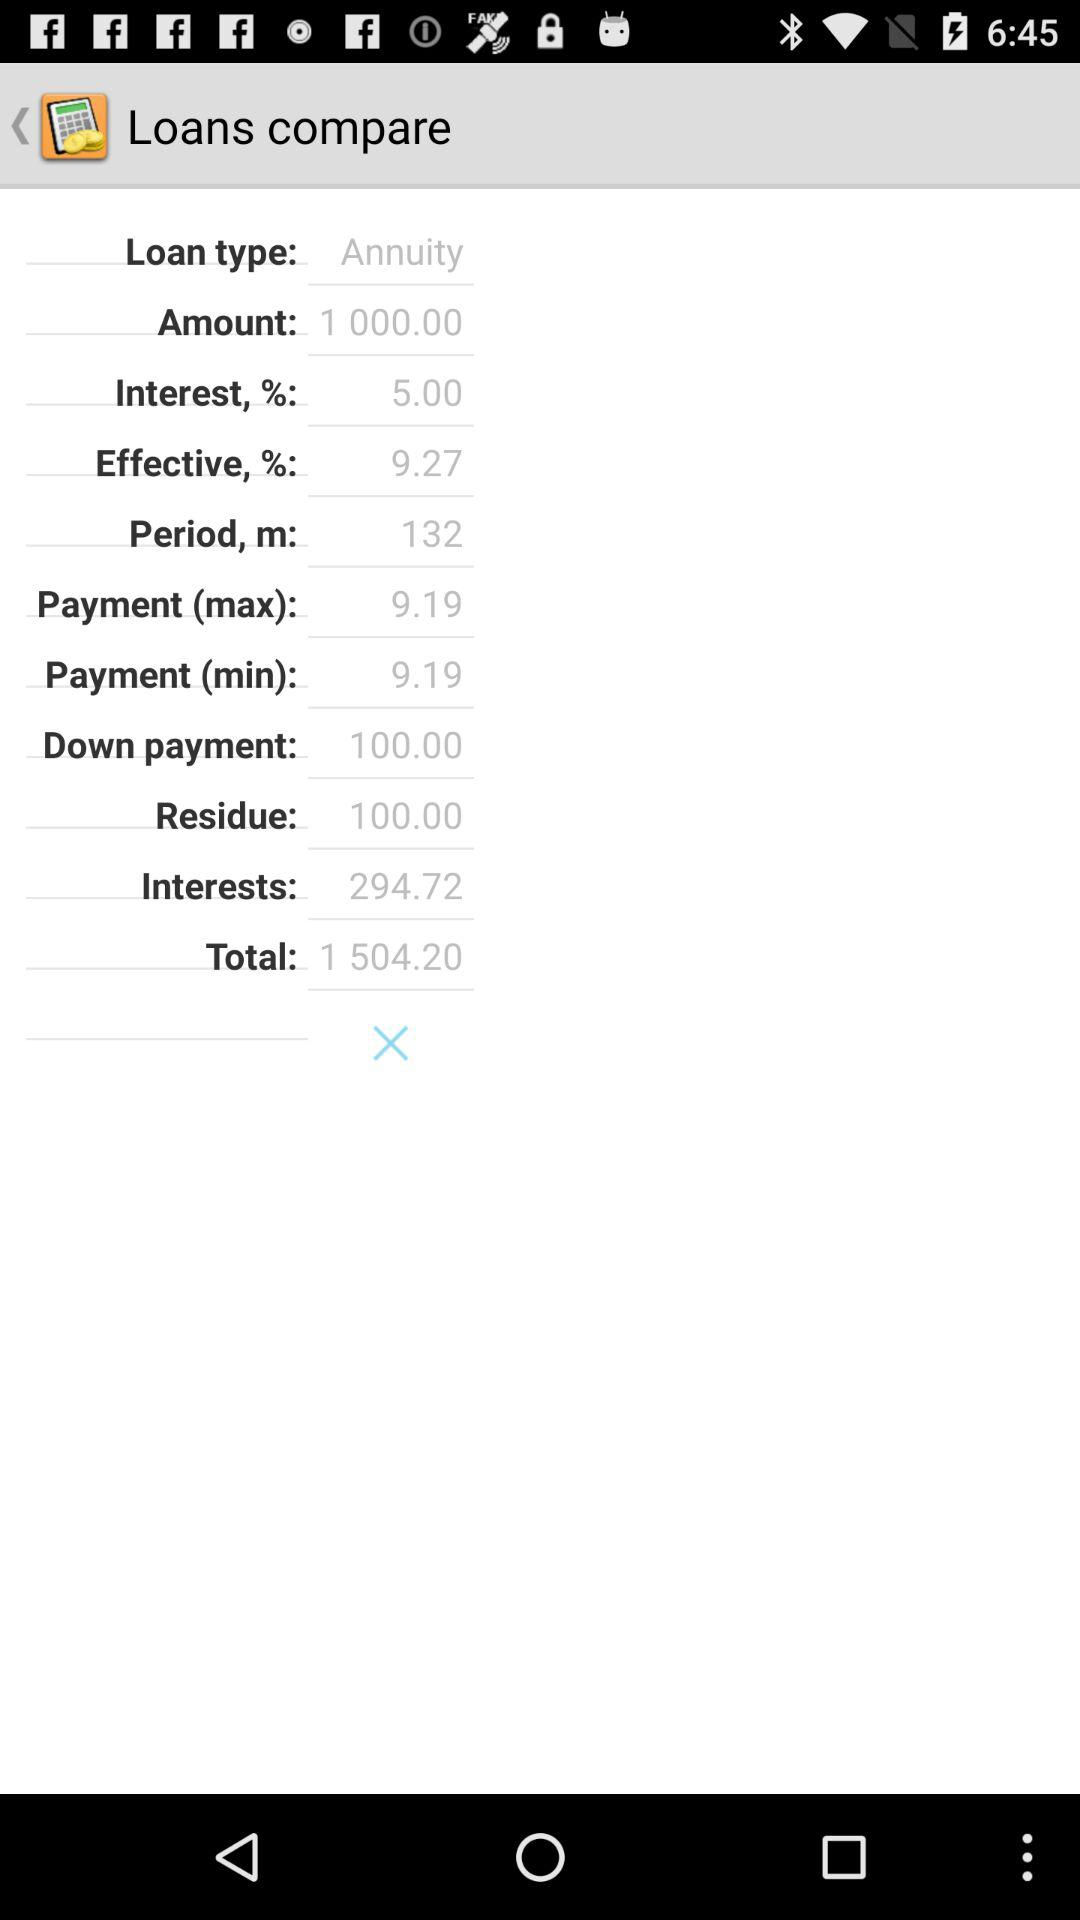What is the total amount of interest paid over the loan period?
Answer the question using a single word or phrase. 294.72 